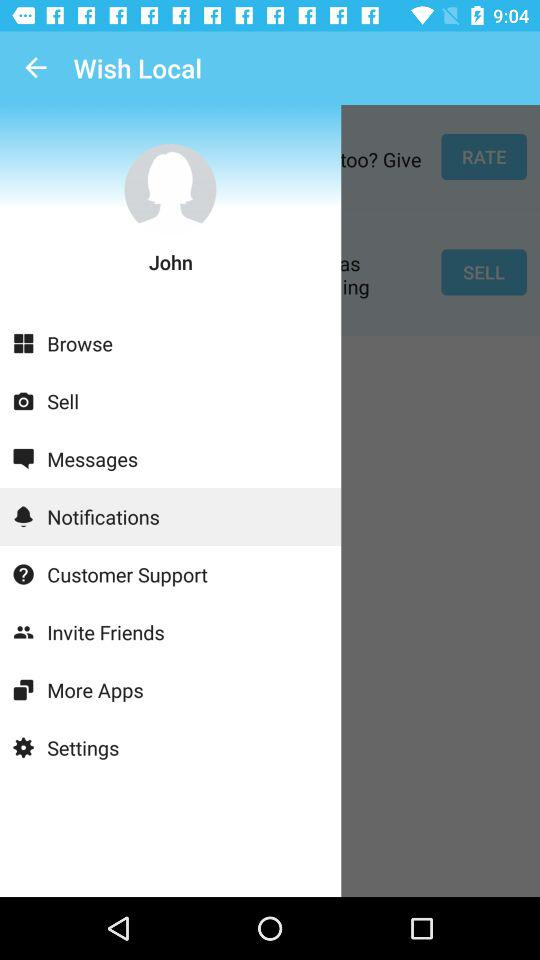What is the user name? The user name is John. 